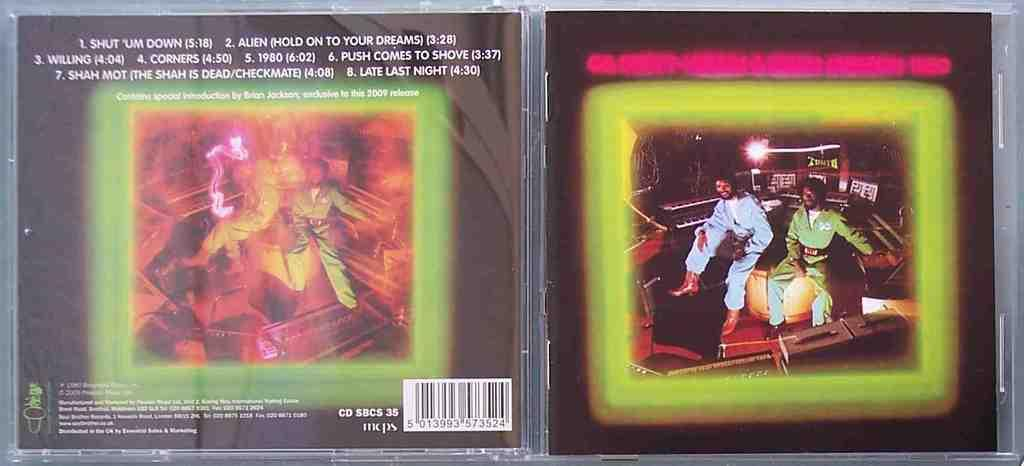<image>
Relay a brief, clear account of the picture shown. A plastic CD case is open showing the songs included on the back cover, one of which is Shut 'um Down 